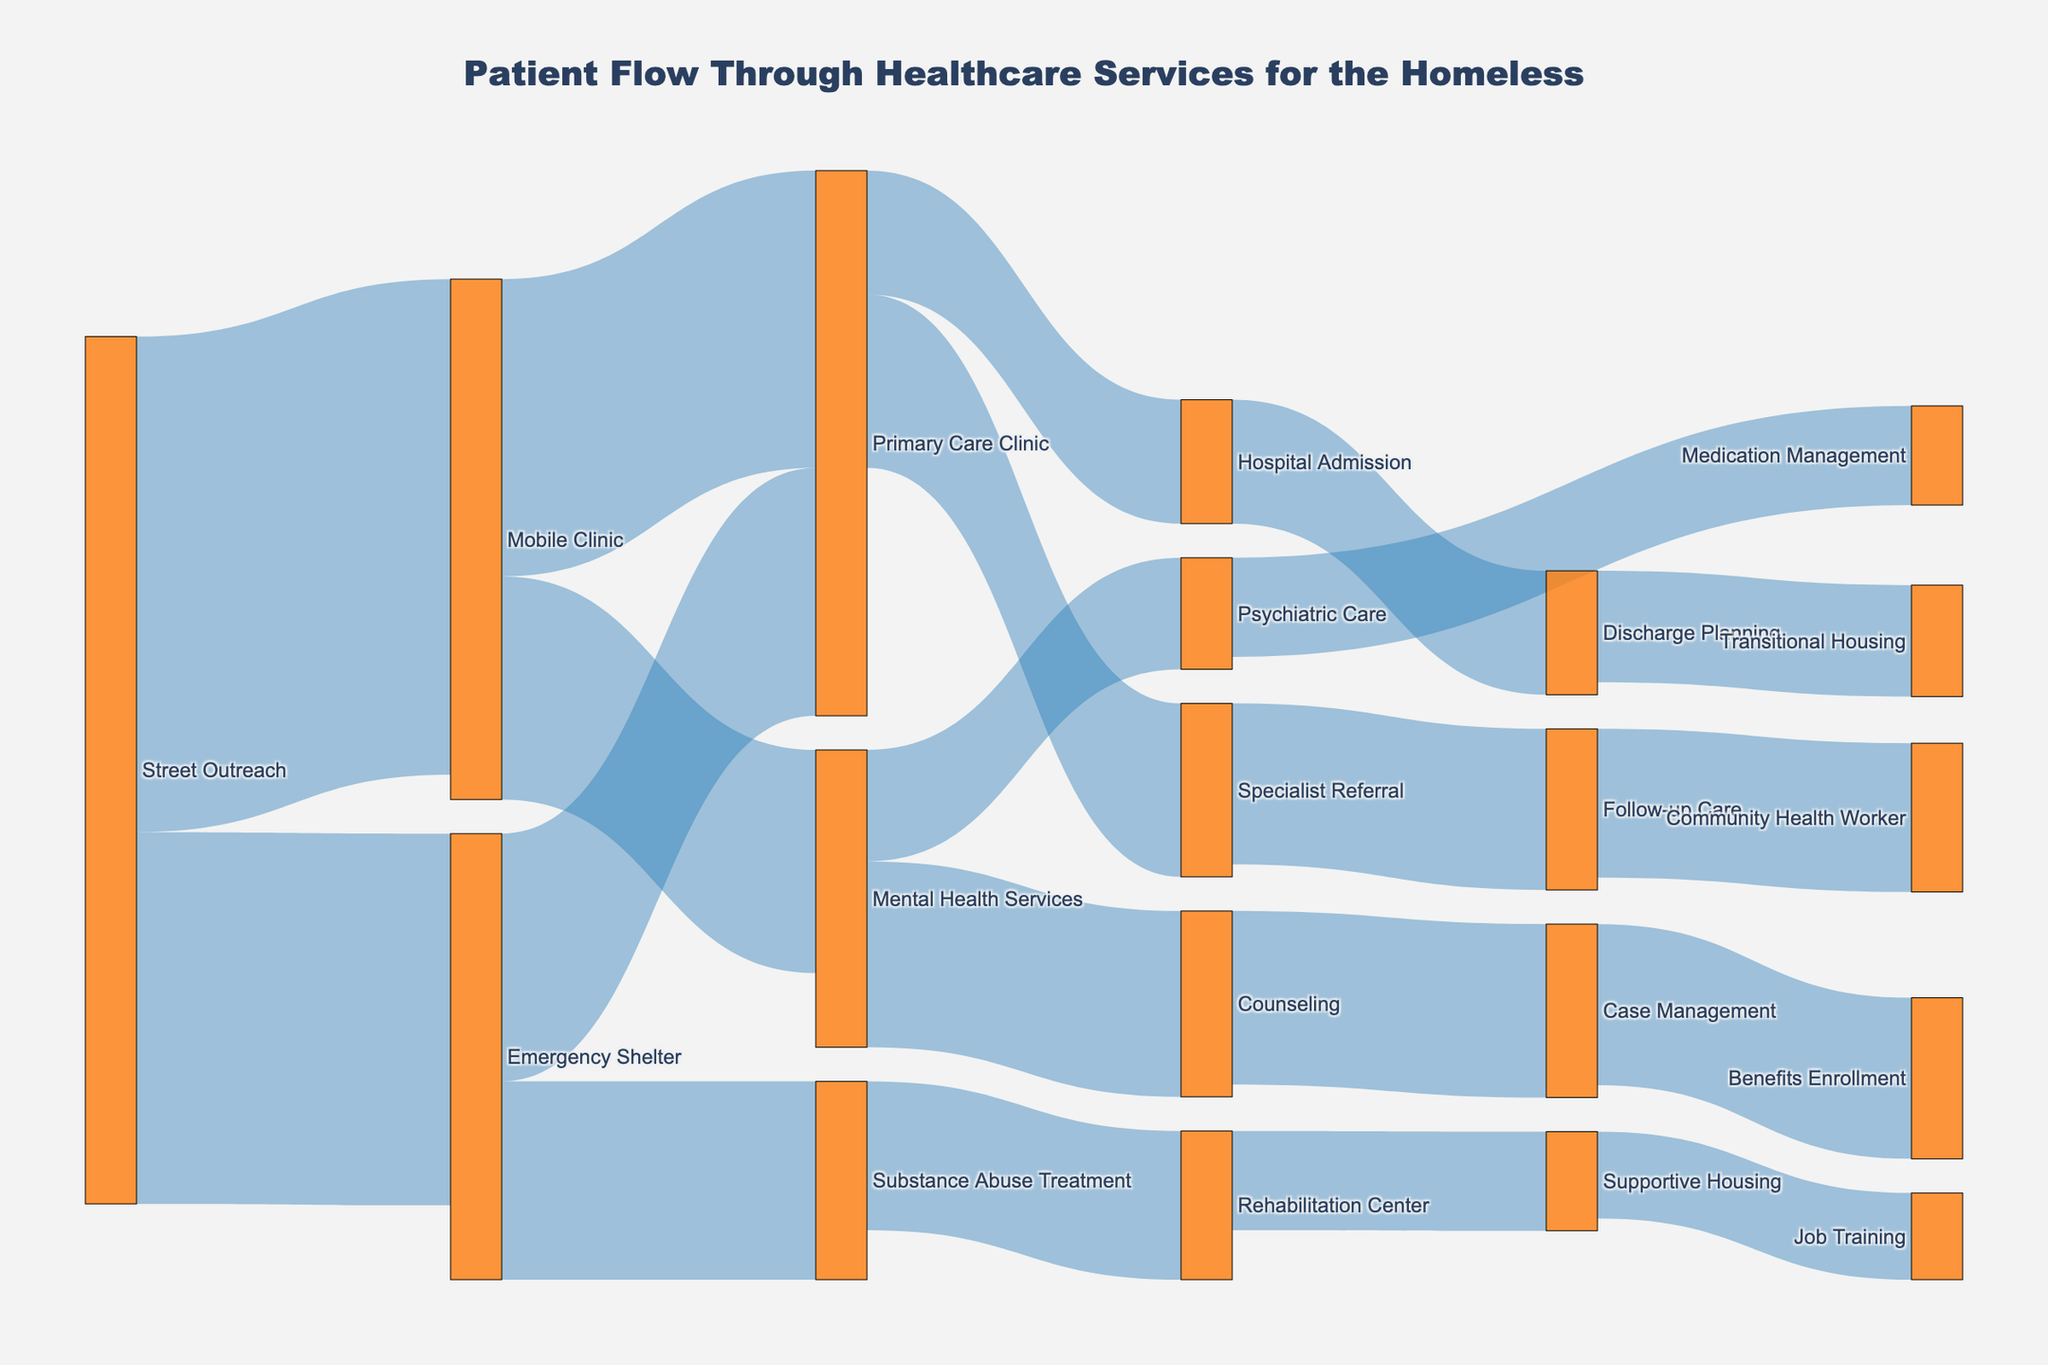What is the title of the diagram? The title can be found at the top of the diagram, which provides a summary or overall description.
Answer: Patient Flow Through Healthcare Services for the Homeless What services do patients move to after Street Outreach? By tracing the flows originating from Street Outreach, we can see that they move to Emergency Shelter and Mobile Clinic.
Answer: Emergency Shelter and Mobile Clinic Which service has the highest number of patients originating from Emergency Shelter? By looking at the flows from Emergency Shelter, we can see that Primary Care Clinic has the highest value.
Answer: Primary Care Clinic What is the total number of patients moving from Street Outreach to any other service? Add the flow values from Street Outreach to Emergency Shelter (150) and Mobile Clinic (200).
Answer: 350 How many patients are moved to Substance Abuse Treatment and Mental Health Services combined? Sum the value of patients from Emergency Shelter to Substance Abuse Treatment (80) and Mobile Clinic to Mental Health Services (90).
Answer: 170 Which service has more patients flowing into Primary Care Clinic: Emergency Shelter or Mobile Clinic? Compare the number of patients flowing from Emergency Shelter (100) and Mobile Clinic (120) to Primary Care Clinic.
Answer: Mobile Clinic What is the subsequent service for patients leaving Hospital Admission? By tracing the flow from Hospital Admission, we see that patients move to Discharge Planning.
Answer: Discharge Planning Which has a higher flow: patients moving from Substance Abuse Treatment to Rehabilitation Center or from Mental Health Services to Counseling? Compare the flow values for both paths: Substance Abuse Treatment to Rehabilitation Center (60) and Mental Health Services to Counseling (75).
Answer: Mental Health Services to Counseling How many patients end up in Supportive Housing via Rehabilitation Center and Job Training combined? Add the values for the flows from Rehabilitation Center to Supportive Housing (40) and Case Management to Benefits Enrollment (65).
Answer: 105 What is the combined flow of patients that go through Primary Care Clinic to other services (Specialist Referral and Hospital Admission)? Sum the values of the flows from Primary Care Clinic to Specialist Referral (70) and Hospital Admission (50).
Answer: 120 